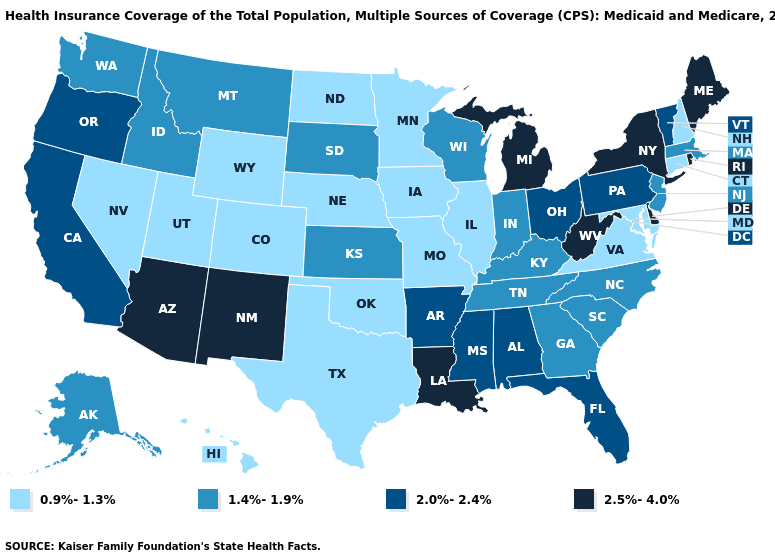Name the states that have a value in the range 2.0%-2.4%?
Write a very short answer. Alabama, Arkansas, California, Florida, Mississippi, Ohio, Oregon, Pennsylvania, Vermont. What is the highest value in the USA?
Short answer required. 2.5%-4.0%. Among the states that border Michigan , which have the lowest value?
Concise answer only. Indiana, Wisconsin. Among the states that border Utah , which have the lowest value?
Answer briefly. Colorado, Nevada, Wyoming. What is the lowest value in the MidWest?
Keep it brief. 0.9%-1.3%. What is the lowest value in the West?
Keep it brief. 0.9%-1.3%. What is the value of Nevada?
Give a very brief answer. 0.9%-1.3%. What is the lowest value in the USA?
Quick response, please. 0.9%-1.3%. Among the states that border Arizona , does California have the lowest value?
Concise answer only. No. How many symbols are there in the legend?
Give a very brief answer. 4. What is the highest value in states that border Texas?
Quick response, please. 2.5%-4.0%. Which states have the highest value in the USA?
Concise answer only. Arizona, Delaware, Louisiana, Maine, Michigan, New Mexico, New York, Rhode Island, West Virginia. Name the states that have a value in the range 0.9%-1.3%?
Answer briefly. Colorado, Connecticut, Hawaii, Illinois, Iowa, Maryland, Minnesota, Missouri, Nebraska, Nevada, New Hampshire, North Dakota, Oklahoma, Texas, Utah, Virginia, Wyoming. Among the states that border Louisiana , does Texas have the highest value?
Keep it brief. No. What is the value of Michigan?
Short answer required. 2.5%-4.0%. 